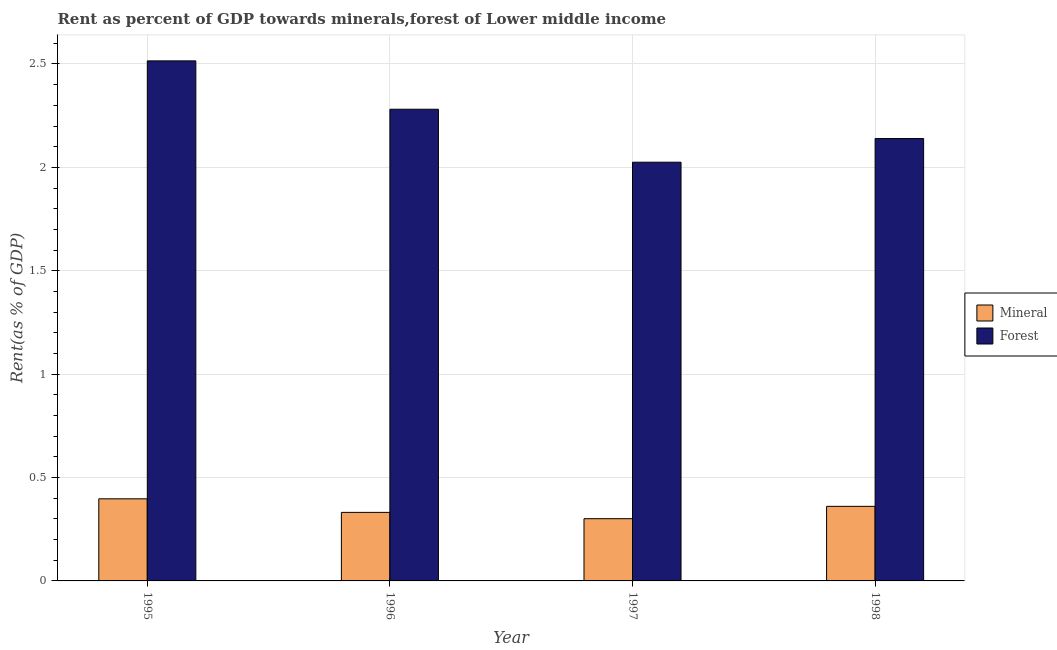How many groups of bars are there?
Your answer should be very brief. 4. Are the number of bars per tick equal to the number of legend labels?
Offer a very short reply. Yes. Are the number of bars on each tick of the X-axis equal?
Your answer should be compact. Yes. How many bars are there on the 4th tick from the left?
Keep it short and to the point. 2. How many bars are there on the 2nd tick from the right?
Your answer should be very brief. 2. What is the label of the 4th group of bars from the left?
Provide a succinct answer. 1998. What is the mineral rent in 1995?
Provide a succinct answer. 0.4. Across all years, what is the maximum forest rent?
Your response must be concise. 2.51. Across all years, what is the minimum mineral rent?
Provide a succinct answer. 0.3. In which year was the mineral rent maximum?
Give a very brief answer. 1995. In which year was the mineral rent minimum?
Give a very brief answer. 1997. What is the total forest rent in the graph?
Your answer should be very brief. 8.96. What is the difference between the mineral rent in 1995 and that in 1996?
Keep it short and to the point. 0.07. What is the difference between the mineral rent in 1995 and the forest rent in 1997?
Provide a succinct answer. 0.1. What is the average forest rent per year?
Your answer should be very brief. 2.24. In how many years, is the forest rent greater than 2.1 %?
Ensure brevity in your answer.  3. What is the ratio of the mineral rent in 1995 to that in 1997?
Provide a short and direct response. 1.32. Is the mineral rent in 1995 less than that in 1998?
Your response must be concise. No. What is the difference between the highest and the second highest mineral rent?
Offer a terse response. 0.04. What is the difference between the highest and the lowest mineral rent?
Your answer should be compact. 0.1. In how many years, is the mineral rent greater than the average mineral rent taken over all years?
Offer a terse response. 2. Is the sum of the mineral rent in 1997 and 1998 greater than the maximum forest rent across all years?
Provide a succinct answer. Yes. What does the 2nd bar from the left in 1998 represents?
Offer a very short reply. Forest. What does the 1st bar from the right in 1995 represents?
Provide a short and direct response. Forest. How many bars are there?
Make the answer very short. 8. Are all the bars in the graph horizontal?
Provide a short and direct response. No. How many years are there in the graph?
Your response must be concise. 4. What is the difference between two consecutive major ticks on the Y-axis?
Give a very brief answer. 0.5. Where does the legend appear in the graph?
Provide a short and direct response. Center right. How many legend labels are there?
Provide a short and direct response. 2. How are the legend labels stacked?
Make the answer very short. Vertical. What is the title of the graph?
Give a very brief answer. Rent as percent of GDP towards minerals,forest of Lower middle income. Does "Under five" appear as one of the legend labels in the graph?
Give a very brief answer. No. What is the label or title of the Y-axis?
Offer a terse response. Rent(as % of GDP). What is the Rent(as % of GDP) in Mineral in 1995?
Provide a succinct answer. 0.4. What is the Rent(as % of GDP) of Forest in 1995?
Give a very brief answer. 2.51. What is the Rent(as % of GDP) in Mineral in 1996?
Your response must be concise. 0.33. What is the Rent(as % of GDP) in Forest in 1996?
Your response must be concise. 2.28. What is the Rent(as % of GDP) of Mineral in 1997?
Provide a short and direct response. 0.3. What is the Rent(as % of GDP) of Forest in 1997?
Make the answer very short. 2.02. What is the Rent(as % of GDP) in Mineral in 1998?
Your answer should be very brief. 0.36. What is the Rent(as % of GDP) in Forest in 1998?
Keep it short and to the point. 2.14. Across all years, what is the maximum Rent(as % of GDP) of Mineral?
Provide a succinct answer. 0.4. Across all years, what is the maximum Rent(as % of GDP) of Forest?
Your response must be concise. 2.51. Across all years, what is the minimum Rent(as % of GDP) in Mineral?
Keep it short and to the point. 0.3. Across all years, what is the minimum Rent(as % of GDP) in Forest?
Provide a short and direct response. 2.02. What is the total Rent(as % of GDP) in Mineral in the graph?
Your answer should be very brief. 1.39. What is the total Rent(as % of GDP) in Forest in the graph?
Offer a terse response. 8.96. What is the difference between the Rent(as % of GDP) in Mineral in 1995 and that in 1996?
Your answer should be compact. 0.07. What is the difference between the Rent(as % of GDP) in Forest in 1995 and that in 1996?
Provide a succinct answer. 0.23. What is the difference between the Rent(as % of GDP) in Mineral in 1995 and that in 1997?
Provide a short and direct response. 0.1. What is the difference between the Rent(as % of GDP) in Forest in 1995 and that in 1997?
Offer a very short reply. 0.49. What is the difference between the Rent(as % of GDP) of Mineral in 1995 and that in 1998?
Your answer should be very brief. 0.04. What is the difference between the Rent(as % of GDP) in Forest in 1995 and that in 1998?
Ensure brevity in your answer.  0.38. What is the difference between the Rent(as % of GDP) in Mineral in 1996 and that in 1997?
Your answer should be very brief. 0.03. What is the difference between the Rent(as % of GDP) in Forest in 1996 and that in 1997?
Offer a terse response. 0.26. What is the difference between the Rent(as % of GDP) in Mineral in 1996 and that in 1998?
Give a very brief answer. -0.03. What is the difference between the Rent(as % of GDP) in Forest in 1996 and that in 1998?
Offer a very short reply. 0.14. What is the difference between the Rent(as % of GDP) in Mineral in 1997 and that in 1998?
Offer a terse response. -0.06. What is the difference between the Rent(as % of GDP) of Forest in 1997 and that in 1998?
Give a very brief answer. -0.11. What is the difference between the Rent(as % of GDP) in Mineral in 1995 and the Rent(as % of GDP) in Forest in 1996?
Offer a terse response. -1.88. What is the difference between the Rent(as % of GDP) in Mineral in 1995 and the Rent(as % of GDP) in Forest in 1997?
Give a very brief answer. -1.63. What is the difference between the Rent(as % of GDP) in Mineral in 1995 and the Rent(as % of GDP) in Forest in 1998?
Provide a short and direct response. -1.74. What is the difference between the Rent(as % of GDP) of Mineral in 1996 and the Rent(as % of GDP) of Forest in 1997?
Ensure brevity in your answer.  -1.69. What is the difference between the Rent(as % of GDP) of Mineral in 1996 and the Rent(as % of GDP) of Forest in 1998?
Your response must be concise. -1.81. What is the difference between the Rent(as % of GDP) in Mineral in 1997 and the Rent(as % of GDP) in Forest in 1998?
Offer a very short reply. -1.84. What is the average Rent(as % of GDP) of Mineral per year?
Provide a succinct answer. 0.35. What is the average Rent(as % of GDP) of Forest per year?
Your response must be concise. 2.24. In the year 1995, what is the difference between the Rent(as % of GDP) in Mineral and Rent(as % of GDP) in Forest?
Your answer should be very brief. -2.12. In the year 1996, what is the difference between the Rent(as % of GDP) in Mineral and Rent(as % of GDP) in Forest?
Keep it short and to the point. -1.95. In the year 1997, what is the difference between the Rent(as % of GDP) of Mineral and Rent(as % of GDP) of Forest?
Your response must be concise. -1.72. In the year 1998, what is the difference between the Rent(as % of GDP) in Mineral and Rent(as % of GDP) in Forest?
Offer a terse response. -1.78. What is the ratio of the Rent(as % of GDP) of Mineral in 1995 to that in 1996?
Offer a very short reply. 1.2. What is the ratio of the Rent(as % of GDP) of Forest in 1995 to that in 1996?
Your answer should be very brief. 1.1. What is the ratio of the Rent(as % of GDP) of Mineral in 1995 to that in 1997?
Make the answer very short. 1.32. What is the ratio of the Rent(as % of GDP) of Forest in 1995 to that in 1997?
Give a very brief answer. 1.24. What is the ratio of the Rent(as % of GDP) of Mineral in 1995 to that in 1998?
Your answer should be very brief. 1.1. What is the ratio of the Rent(as % of GDP) in Forest in 1995 to that in 1998?
Offer a terse response. 1.18. What is the ratio of the Rent(as % of GDP) in Mineral in 1996 to that in 1997?
Make the answer very short. 1.1. What is the ratio of the Rent(as % of GDP) in Forest in 1996 to that in 1997?
Ensure brevity in your answer.  1.13. What is the ratio of the Rent(as % of GDP) of Mineral in 1996 to that in 1998?
Provide a short and direct response. 0.92. What is the ratio of the Rent(as % of GDP) in Forest in 1996 to that in 1998?
Keep it short and to the point. 1.07. What is the ratio of the Rent(as % of GDP) in Mineral in 1997 to that in 1998?
Your answer should be very brief. 0.83. What is the ratio of the Rent(as % of GDP) in Forest in 1997 to that in 1998?
Ensure brevity in your answer.  0.95. What is the difference between the highest and the second highest Rent(as % of GDP) in Mineral?
Give a very brief answer. 0.04. What is the difference between the highest and the second highest Rent(as % of GDP) in Forest?
Offer a very short reply. 0.23. What is the difference between the highest and the lowest Rent(as % of GDP) of Mineral?
Your answer should be compact. 0.1. What is the difference between the highest and the lowest Rent(as % of GDP) of Forest?
Offer a terse response. 0.49. 